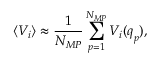Convert formula to latex. <formula><loc_0><loc_0><loc_500><loc_500>\langle V _ { i } \rangle \approx \frac { 1 } { N _ { M P } } \sum _ { p = 1 } ^ { N _ { M P } } V _ { i } ( q _ { p } ) ,</formula> 